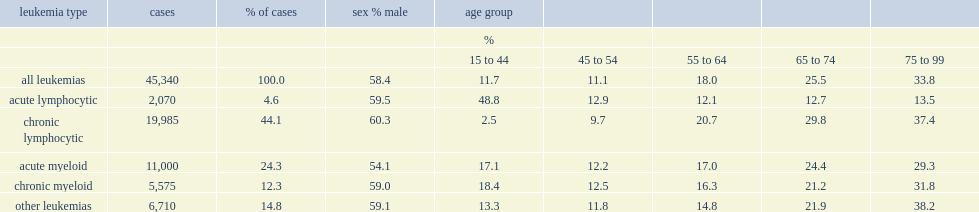Among leukemia cases diagnosed at ages 15 to 99 from 1992 to 2008 and eligible for survival analysis, what is the percentage of the most common type? 44.1. Among leukemia cases diagnosed at ages 15 to 99 from 1992 to 2008 and eligible for survival analysis,what is the percentage of all? 4.6. What is the percentage of cases diagnosed in men was highest for cll at ages 15 to 99 from 1992 to 2008? 60.3. What is the percentage of cases diagnosed in men was lowest for aml at ages 15 to 99 from 1992 to 2008? 54.1. The most skewed age distributions were for cll and all. cll was much more likely to be diagnosed at older ages, and was rarely detected at ages 15 to 44 from 1992 to 2008, what is the percentage of it? 2.5. By contrast, what is the percentage of non-childhood all cases were diagnosed before age 45 from 1992 to 2008? 48.8. 